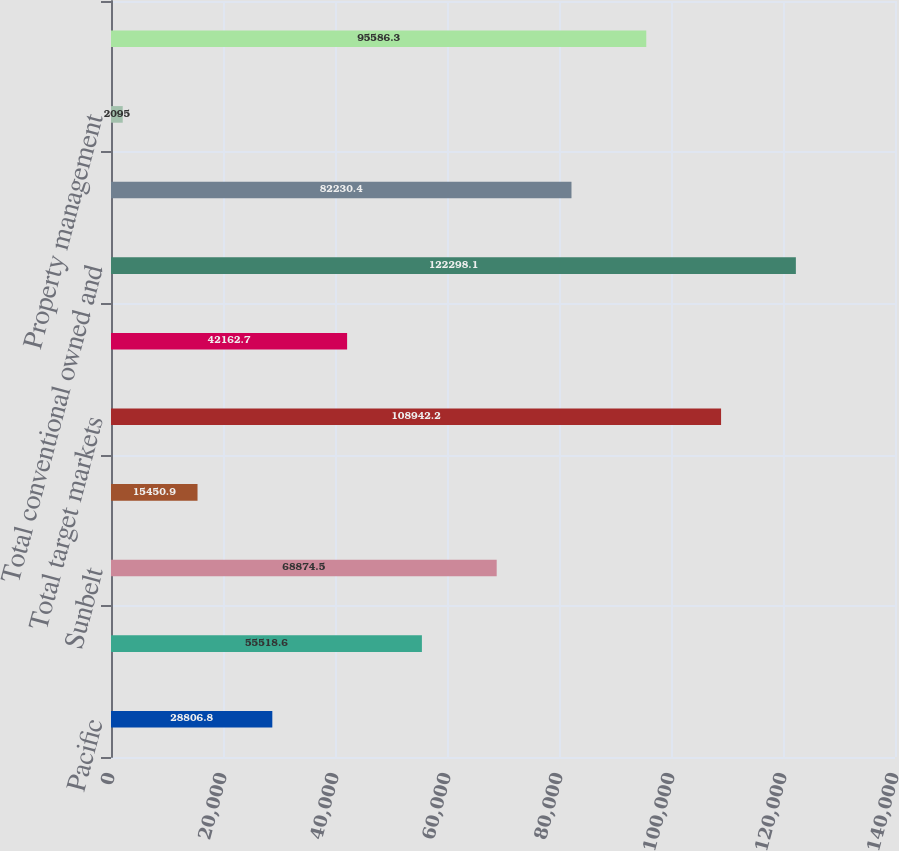<chart> <loc_0><loc_0><loc_500><loc_500><bar_chart><fcel>Pacific<fcel>Northeast<fcel>Sunbelt<fcel>Chicago<fcel>Total target markets<fcel>Opportunistic and other<fcel>Total conventional owned and<fcel>Affordable owned and managed<fcel>Property management<fcel>Asset management<nl><fcel>28806.8<fcel>55518.6<fcel>68874.5<fcel>15450.9<fcel>108942<fcel>42162.7<fcel>122298<fcel>82230.4<fcel>2095<fcel>95586.3<nl></chart> 